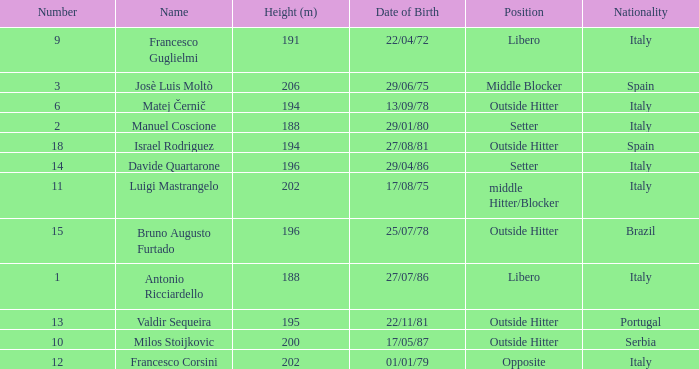Name the height for date of birth being 17/08/75 202.0. 